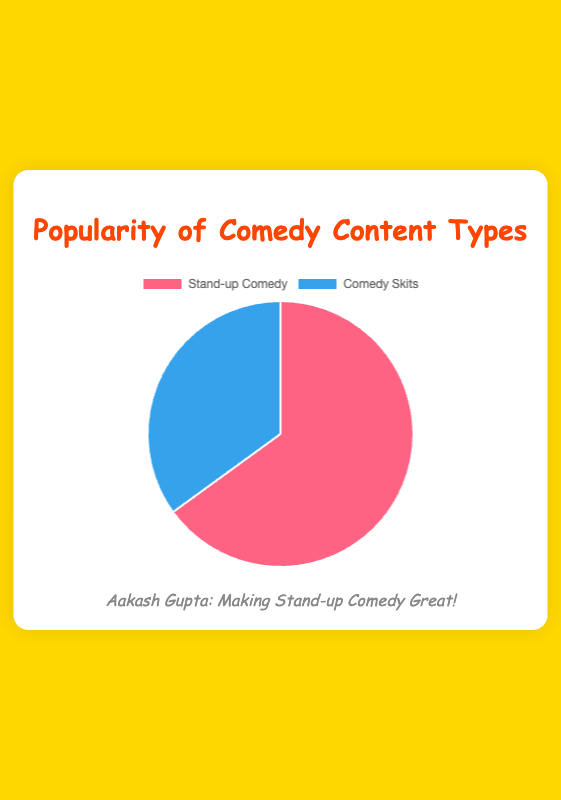What percentage of the total popularity is Stand-up Comedy? The pie chart shows the popularity percentages of different types of comedy content. Stand-up Comedy has a popularity percentage of 65%.
Answer: 65% How much more popular is Stand-up Comedy compared to Comedy Skits? According to the pie chart, the popularity percentage of Stand-up Comedy is 65% and that of Comedy Skits is 35%. The difference is 65% - 35% = 30%.
Answer: 30% Which type of comedy content is more popular? The pie chart indicates that Stand-up Comedy has a higher popularity percentage (65%) compared to Comedy Skits (35%).
Answer: Stand-up Comedy What is the combined popularity of both types of comedy content? From the pie chart, Stand-up Comedy has 65% and Comedy Skits has 35%. Adding these, 65% + 35% = 100%.
Answer: 100% If the total popularity is represented as 100 people, how many people prefer Stand-up Comedy? The pie chart shows that Stand-up Comedy has a 65% popularity. So, out of 100 people, 65% prefer Stand-up Comedy, which is 65 people.
Answer: 65 Which section of the pie chart is larger based on the visual representation? The pie chart visually represents Stand-up Comedy with a larger section than Comedy Skits, indicating its higher popularity.
Answer: Stand-up Comedy By what factor is Stand-up Comedy more popular than Comedy Skits? Stand-up Comedy has a popularity of 65%, and Comedy Skits has 35%. The factor is calculated as 65 / 35, which simplifies to approximately 1.86.
Answer: 1.86 Identify the colors representing Stand-up Comedy and Comedy Skits in the pie chart. In the pie chart, Stand-up Comedy is represented by red, and Comedy Skits is represented by blue.
Answer: Red and Blue 